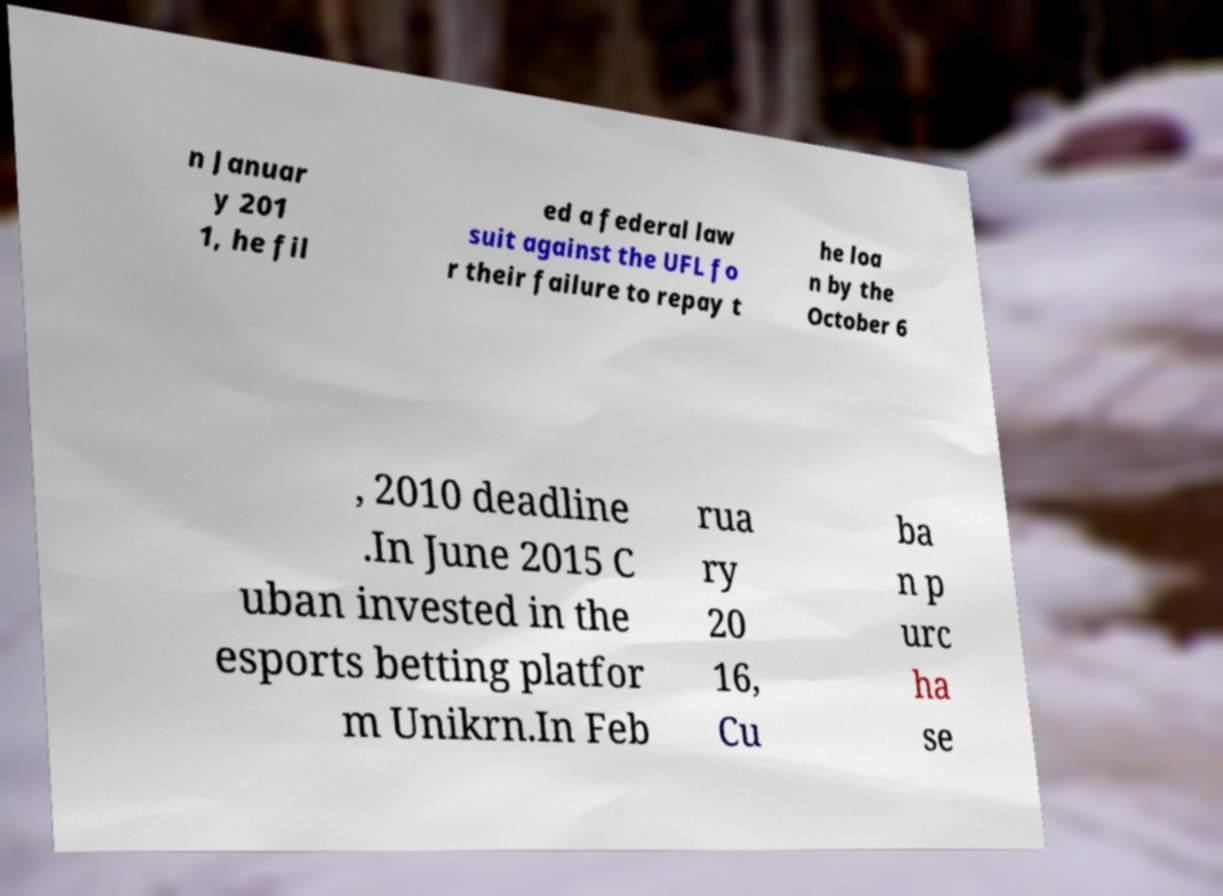Please read and relay the text visible in this image. What does it say? n Januar y 201 1, he fil ed a federal law suit against the UFL fo r their failure to repay t he loa n by the October 6 , 2010 deadline .In June 2015 C uban invested in the esports betting platfor m Unikrn.In Feb rua ry 20 16, Cu ba n p urc ha se 